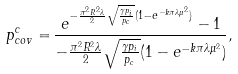Convert formula to latex. <formula><loc_0><loc_0><loc_500><loc_500>p _ { c o v } ^ { c } = & \, \frac { e ^ { - \frac { \pi ^ { 2 } R ^ { 2 } \lambda } { 2 } \sqrt { \frac { \gamma p _ { i } } { p _ { c } } } ( 1 - e ^ { - k \pi \lambda \mu ^ { 2 } } ) } - 1 } { - \frac { \pi ^ { 2 } R ^ { 2 } \lambda } { 2 } \sqrt { \frac { \gamma p _ { i } } { p _ { c } } } ( 1 - e ^ { - k \pi \lambda \mu ^ { 2 } } ) } ,</formula> 